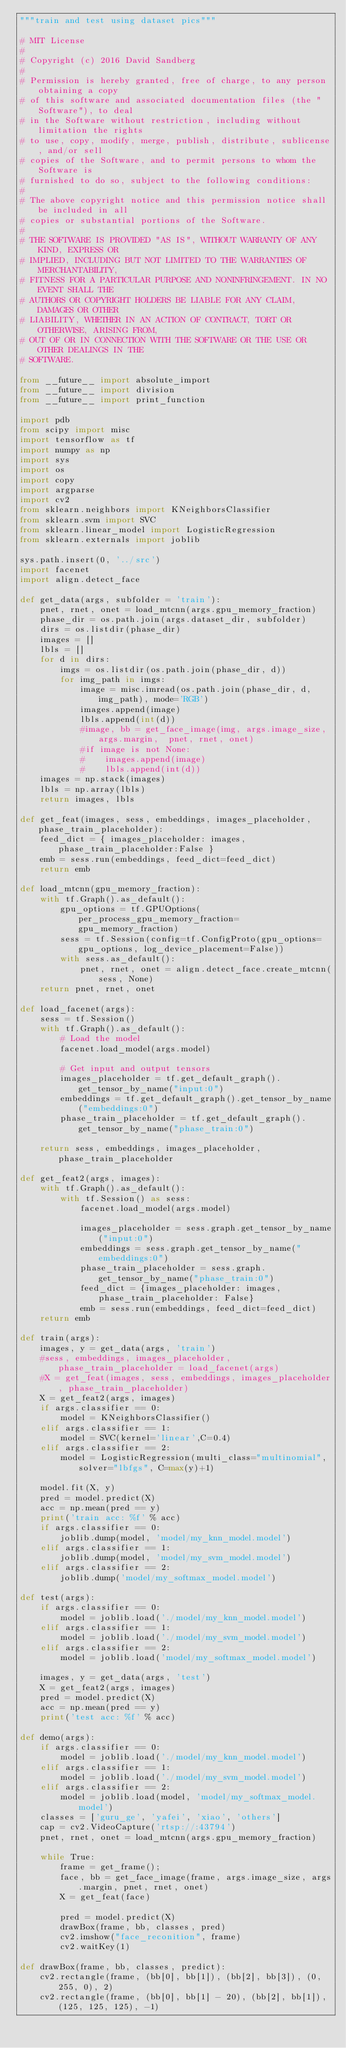<code> <loc_0><loc_0><loc_500><loc_500><_Python_>"""train and test using dataset pics"""

# MIT License
# 
# Copyright (c) 2016 David Sandberg
# 
# Permission is hereby granted, free of charge, to any person obtaining a copy
# of this software and associated documentation files (the "Software"), to deal
# in the Software without restriction, including without limitation the rights
# to use, copy, modify, merge, publish, distribute, sublicense, and/or sell
# copies of the Software, and to permit persons to whom the Software is
# furnished to do so, subject to the following conditions:
# 
# The above copyright notice and this permission notice shall be included in all
# copies or substantial portions of the Software.
# 
# THE SOFTWARE IS PROVIDED "AS IS", WITHOUT WARRANTY OF ANY KIND, EXPRESS OR
# IMPLIED, INCLUDING BUT NOT LIMITED TO THE WARRANTIES OF MERCHANTABILITY,
# FITNESS FOR A PARTICULAR PURPOSE AND NONINFRINGEMENT. IN NO EVENT SHALL THE
# AUTHORS OR COPYRIGHT HOLDERS BE LIABLE FOR ANY CLAIM, DAMAGES OR OTHER
# LIABILITY, WHETHER IN AN ACTION OF CONTRACT, TORT OR OTHERWISE, ARISING FROM,
# OUT OF OR IN CONNECTION WITH THE SOFTWARE OR THE USE OR OTHER DEALINGS IN THE
# SOFTWARE.

from __future__ import absolute_import
from __future__ import division
from __future__ import print_function

import pdb
from scipy import misc
import tensorflow as tf
import numpy as np
import sys
import os
import copy
import argparse
import cv2
from sklearn.neighbors import KNeighborsClassifier
from sklearn.svm import SVC
from sklearn.linear_model import LogisticRegression
from sklearn.externals import joblib

sys.path.insert(0, '../src')
import facenet
import align.detect_face

def get_data(args, subfolder = 'train'):
    pnet, rnet, onet = load_mtcnn(args.gpu_memory_fraction)
    phase_dir = os.path.join(args.dataset_dir, subfolder)
    dirs = os.listdir(phase_dir)
    images = []
    lbls = []
    for d in dirs:
        imgs = os.listdir(os.path.join(phase_dir, d))
        for img_path in imgs:
            image = misc.imread(os.path.join(phase_dir, d, img_path), mode='RGB')
            images.append(image)
            lbls.append(int(d))
            #image, bb = get_face_image(img, args.image_size, args.margin,  pnet, rnet, onet)
            #if image is not None:
            #    images.append(image)
            #    lbls.append(int(d))
    images = np.stack(images)
    lbls = np.array(lbls)
    return images, lbls

def get_feat(images, sess, embeddings, images_placeholder, phase_train_placeholder):
    feed_dict = { images_placeholder: images, phase_train_placeholder:False }
    emb = sess.run(embeddings, feed_dict=feed_dict)
    return emb

def load_mtcnn(gpu_memory_fraction):
    with tf.Graph().as_default():
        gpu_options = tf.GPUOptions(per_process_gpu_memory_fraction=gpu_memory_fraction)
        sess = tf.Session(config=tf.ConfigProto(gpu_options=gpu_options, log_device_placement=False))
        with sess.as_default():
            pnet, rnet, onet = align.detect_face.create_mtcnn(sess, None)
    return pnet, rnet, onet

def load_facenet(args):
    sess = tf.Session()
    with tf.Graph().as_default():
        # Load the model
        facenet.load_model(args.model)

        # Get input and output tensors
        images_placeholder = tf.get_default_graph().get_tensor_by_name("input:0")
        embeddings = tf.get_default_graph().get_tensor_by_name("embeddings:0")
        phase_train_placeholder = tf.get_default_graph().get_tensor_by_name("phase_train:0")

    return sess, embeddings, images_placeholder, phase_train_placeholder

def get_feat2(args, images):
    with tf.Graph().as_default():
        with tf.Session() as sess:
            facenet.load_model(args.model)

            images_placeholder = sess.graph.get_tensor_by_name("input:0")
            embeddings = sess.graph.get_tensor_by_name("embeddings:0")
            phase_train_placeholder = sess.graph.get_tensor_by_name("phase_train:0")
            feed_dict = {images_placeholder: images, phase_train_placeholder: False}
            emb = sess.run(embeddings, feed_dict=feed_dict)
    return emb

def train(args):
    images, y = get_data(args, 'train')
    #sess, embeddings, images_placeholder, phase_train_placeholder = load_facenet(args)
    #X = get_feat(images, sess, embeddings, images_placeholder, phase_train_placeholder)
    X = get_feat2(args, images)
    if args.classifier == 0:
        model = KNeighborsClassifier()
    elif args.classifier == 1:
        model = SVC(kernel='linear',C=0.4)
    elif args.classifier == 2:
        model = LogisticRegression(multi_class="multinomial", solver="lbfgs", C=max(y)+1)

    model.fit(X, y)
    pred = model.predict(X)
    acc = np.mean(pred == y)
    print('train acc: %f' % acc)
    if args.classifier == 0:
        joblib.dump(model, 'model/my_knn_model.model')
    elif args.classifier == 1:
        joblib.dump(model, 'model/my_svm_model.model')
    elif args.classifier == 2:
        joblib.dump('model/my_softmax_model.model')

def test(args):
    if args.classifier == 0:
        model = joblib.load('./model/my_knn_model.model')
    elif args.classifier == 1:
        model = joblib.load('./model/my_svm_model.model')
    elif args.classifier == 2:
        model = joblib.load('model/my_softmax_model.model')

    images, y = get_data(args, 'test')
    X = get_feat2(args, images)
    pred = model.predict(X)
    acc = np.mean(pred == y)
    print('test acc: %f' % acc)

def demo(args):
    if args.classifier == 0:
        model = joblib.load('./model/my_knn_model.model')
    elif args.classifier == 1:
        model = joblib.load('./model/my_svm_model.model')
    elif args.classifier == 2:
        model = joblib.load(model, 'model/my_softmax_model.model')
    classes = ['guru_ge', 'yafei', 'xiao', 'others']
    cap = cv2.VideoCapture('rtsp://:43794')
    pnet, rnet, onet = load_mtcnn(args.gpu_memory_fraction)

    while True:
        frame = get_frame();
        face, bb = get_face_image(frame, args.image_size, args.margin, pnet, rnet, onet)
        X = get_feat(face)

        pred = model.predict(X)
        drawBox(frame, bb, classes, pred)
        cv2.imshow("face_reconition", frame)
        cv2.waitKey(1)

def drawBox(frame, bb, classes, predict):
    cv2.rectangle(frame, (bb[0], bb[1]), (bb[2], bb[3]), (0, 255, 0), 2)
    cv2.rectangle(frame, (bb[0], bb[1] - 20), (bb[2], bb[1]), (125, 125, 125), -1)</code> 